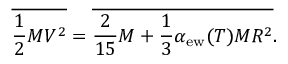Convert formula to latex. <formula><loc_0><loc_0><loc_500><loc_500>{ \overline { { { \frac { 1 } { 2 } M V ^ { 2 } } } } } = { \overline { { { \frac { 2 } { 1 5 } M + \frac { 1 } { 3 } \alpha _ { e w } ( T ) M R ^ { 2 } } } } } .</formula> 